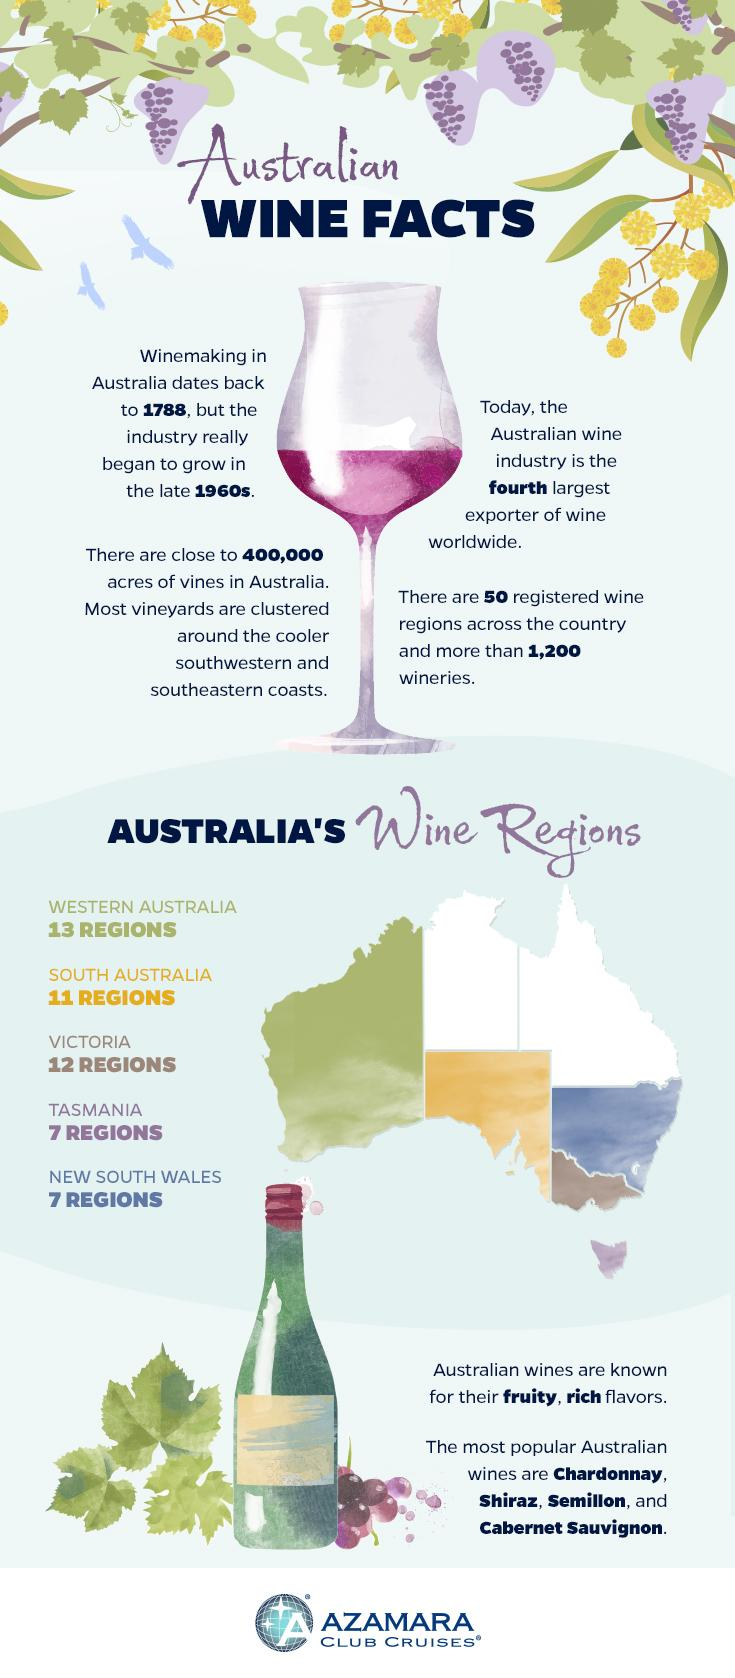Draw attention to some important aspects in this diagram. The wine region of Tasmania appears as an island towards the south-east part of the map. The color that represents South Australia on the map is yellow. The blue color on the map indicates that Tasmania, Western Australia, and New South Wales are the wine regions. Green is the color that is used to fill the largest section in the map. 